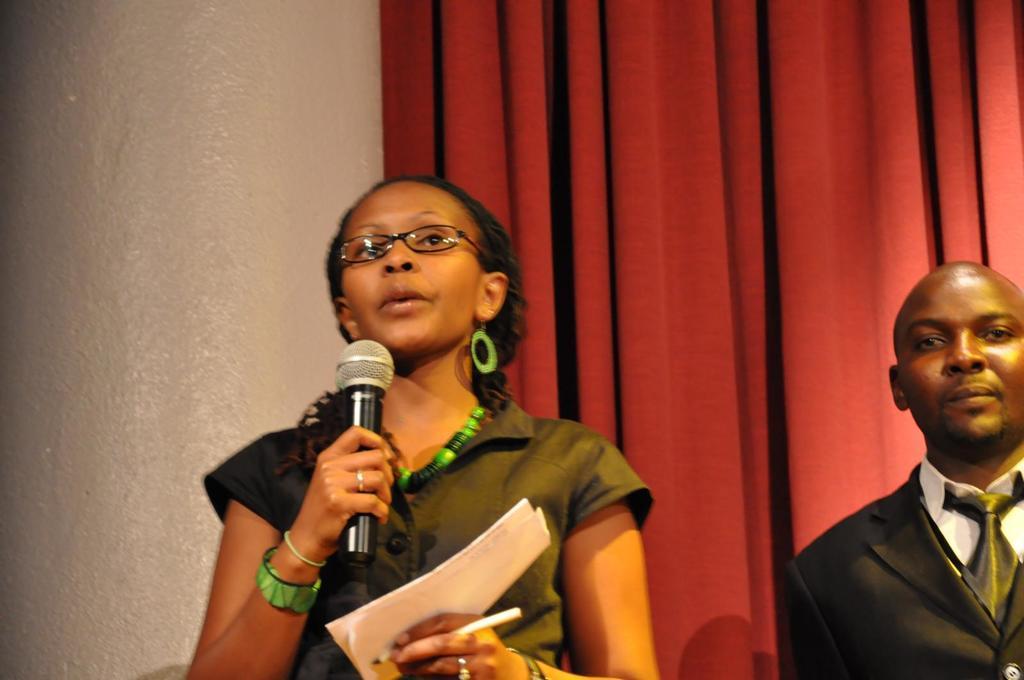Can you describe this image briefly? In this image In the middle there is a woman she is holding paper and mic she is speaking her hair is short. On the right there is a man he wears suit, tie and shirt. In the background there is a curtain and wall. 